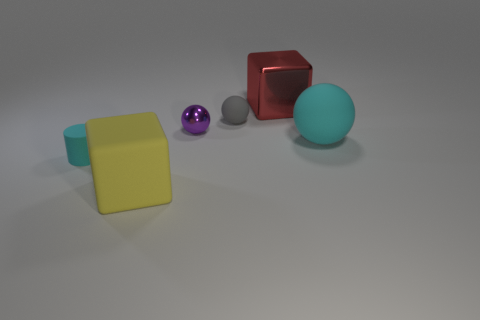What is the texture and lighting like in this scene? The texture of the objects in the image reflects a somewhat plastic or synthetic material with subtle light reflections, indicating a smooth but not overly shiny surface. The lighting in the scene is soft and diffused, casting gentle shadows and highlighting the dimensionality of the objects without creating harsh contrasts. 